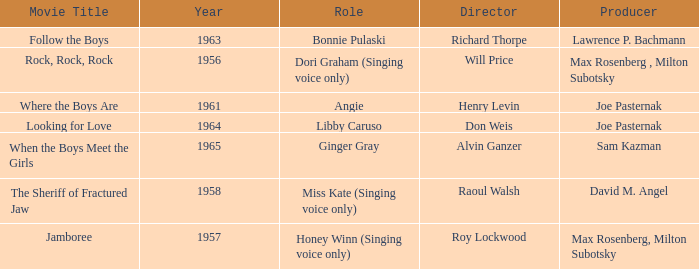What year was Jamboree made? 1957.0. 